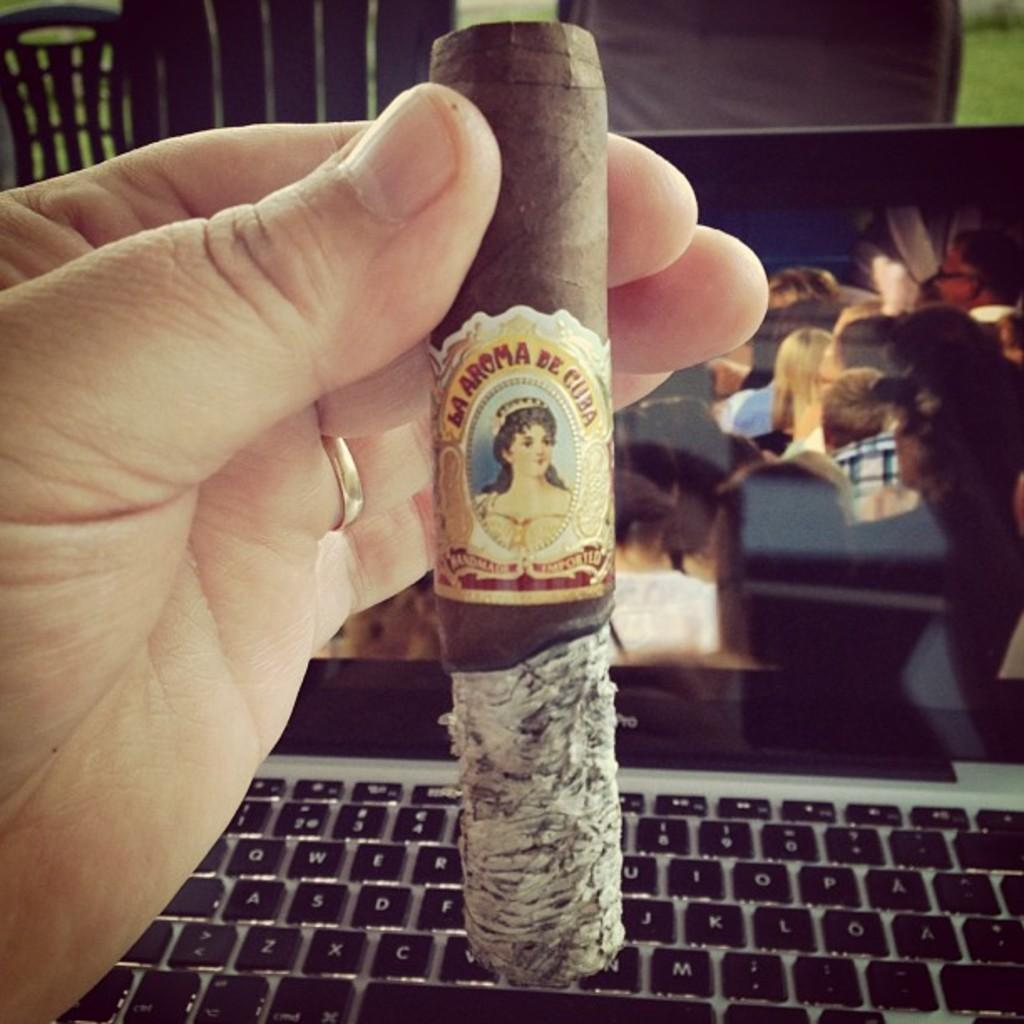Who or what is present in the image? There is a person in the image. What is the person holding in the image? The person is holding a cigar. Can you describe the cigar in the image? The cigar has a label with a person's image. What can be seen in the background of the image? There is a laptop and chairs in the background of the image. What type of soup is being served in the image? There is no soup present in the image. How does the person in the image contribute to the harmony of the scene? The image does not depict a scene where harmony is a factor, and the person's presence does not contribute to any harmony in the image. 